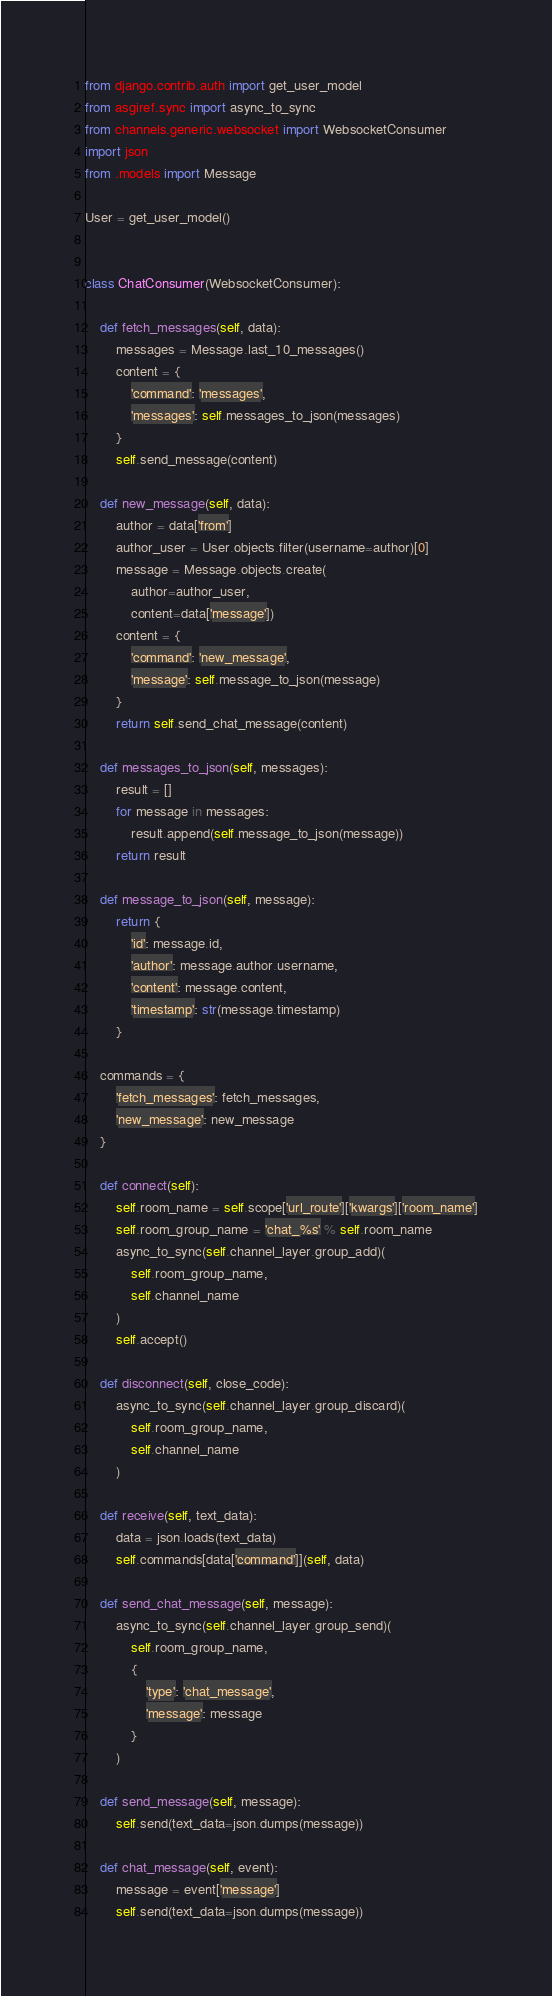<code> <loc_0><loc_0><loc_500><loc_500><_Python_>from django.contrib.auth import get_user_model
from asgiref.sync import async_to_sync
from channels.generic.websocket import WebsocketConsumer
import json
from .models import Message

User = get_user_model()


class ChatConsumer(WebsocketConsumer):

    def fetch_messages(self, data):
        messages = Message.last_10_messages()
        content = {
            'command': 'messages',
            'messages': self.messages_to_json(messages)
        }
        self.send_message(content)

    def new_message(self, data):
        author = data['from']
        author_user = User.objects.filter(username=author)[0]
        message = Message.objects.create(
            author=author_user,
            content=data['message'])
        content = {
            'command': 'new_message',
            'message': self.message_to_json(message)
        }
        return self.send_chat_message(content)

    def messages_to_json(self, messages):
        result = []
        for message in messages:
            result.append(self.message_to_json(message))
        return result

    def message_to_json(self, message):
        return {
            'id': message.id,
            'author': message.author.username,
            'content': message.content,
            'timestamp': str(message.timestamp)
        }

    commands = {
        'fetch_messages': fetch_messages,
        'new_message': new_message
    }

    def connect(self):
        self.room_name = self.scope['url_route']['kwargs']['room_name']
        self.room_group_name = 'chat_%s' % self.room_name
        async_to_sync(self.channel_layer.group_add)(
            self.room_group_name,
            self.channel_name
        )
        self.accept()

    def disconnect(self, close_code):
        async_to_sync(self.channel_layer.group_discard)(
            self.room_group_name,
            self.channel_name
        )

    def receive(self, text_data):
        data = json.loads(text_data)
        self.commands[data['command']](self, data)

    def send_chat_message(self, message):
        async_to_sync(self.channel_layer.group_send)(
            self.room_group_name,
            {
                'type': 'chat_message',
                'message': message
            }
        )

    def send_message(self, message):
        self.send(text_data=json.dumps(message))

    def chat_message(self, event):
        message = event['message']
        self.send(text_data=json.dumps(message))
</code> 